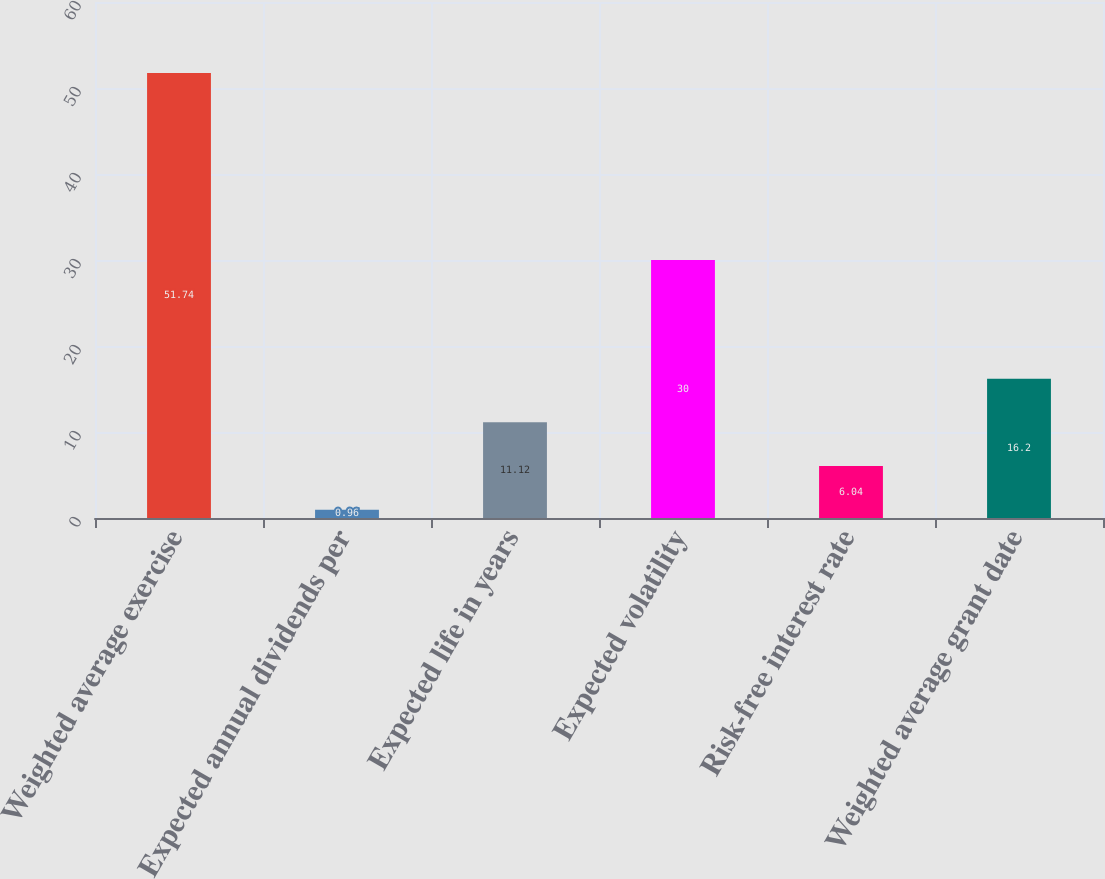Convert chart to OTSL. <chart><loc_0><loc_0><loc_500><loc_500><bar_chart><fcel>Weighted average exercise<fcel>Expected annual dividends per<fcel>Expected life in years<fcel>Expected volatility<fcel>Risk-free interest rate<fcel>Weighted average grant date<nl><fcel>51.74<fcel>0.96<fcel>11.12<fcel>30<fcel>6.04<fcel>16.2<nl></chart> 